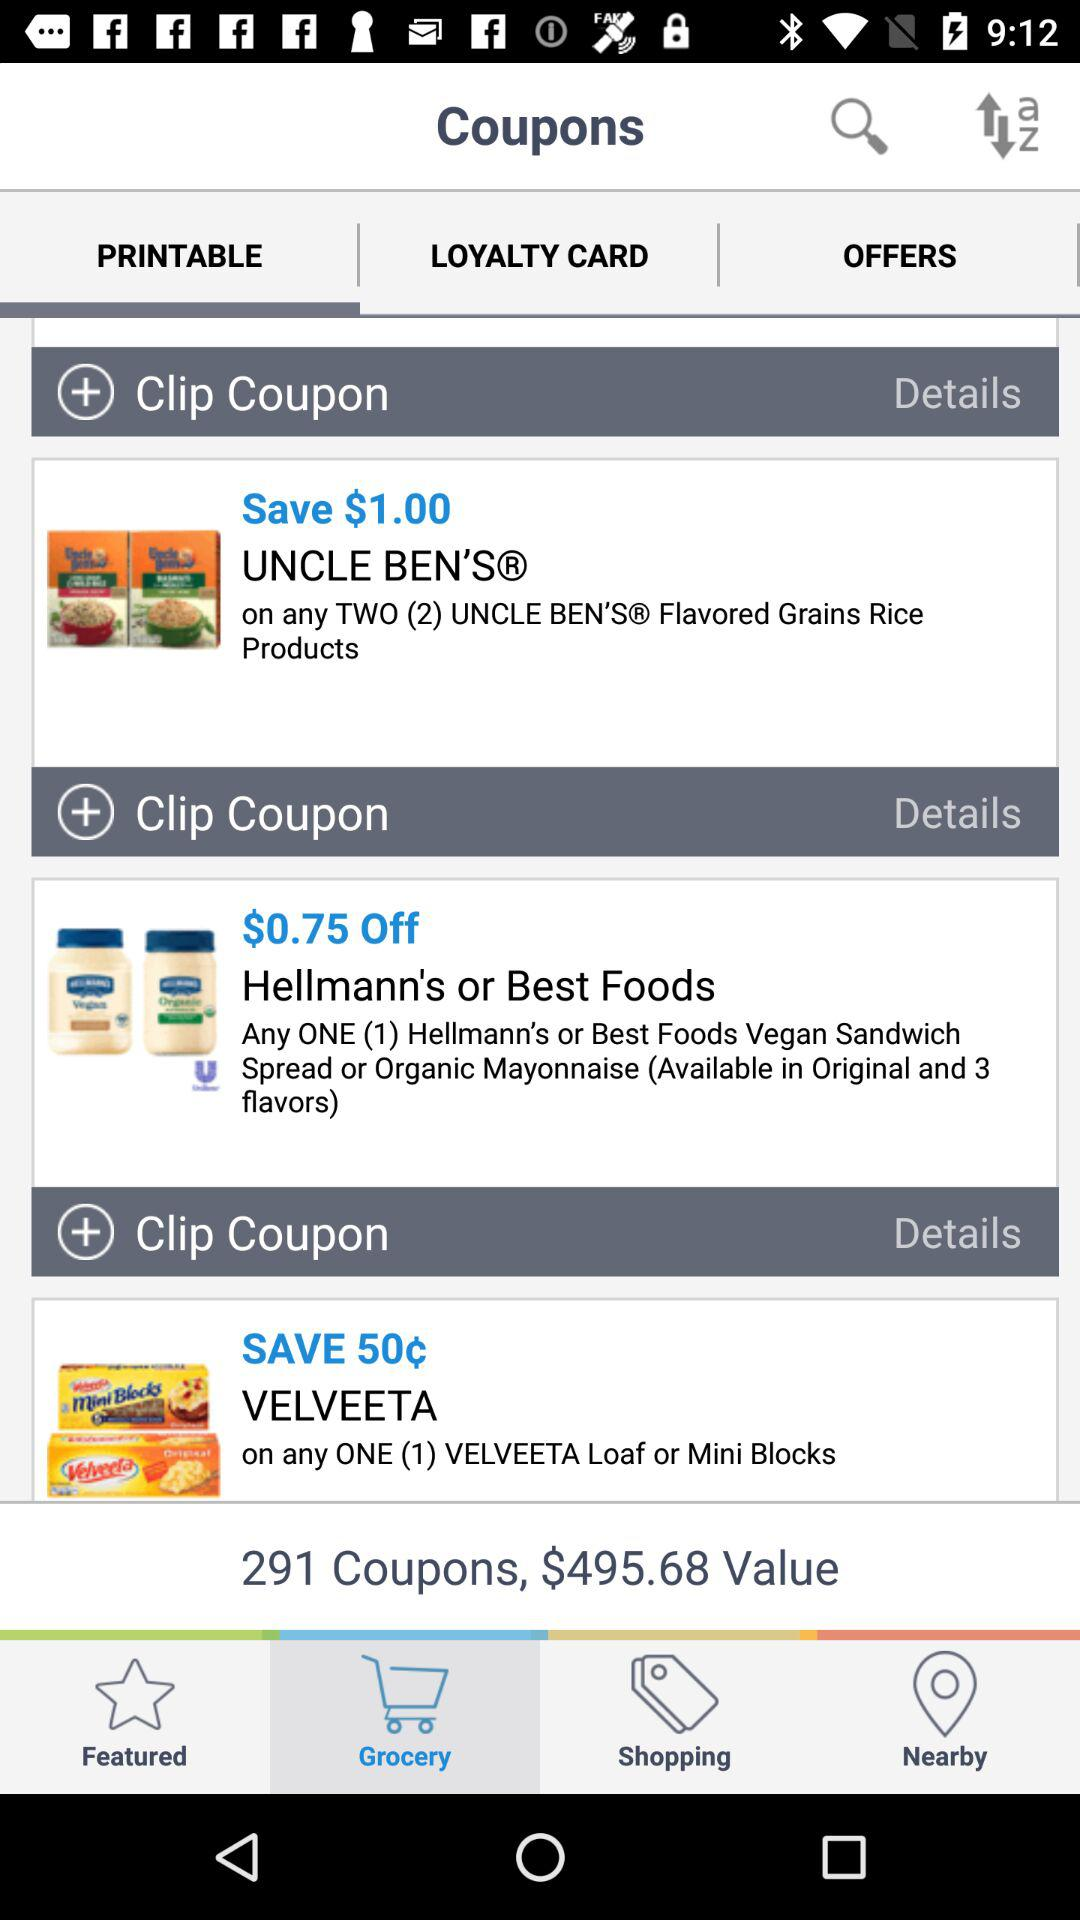What amount of money is off on "Hellmann's or Best Foods"? The amount of money off on "Hellmann's or Best Foods" is $0.75. 